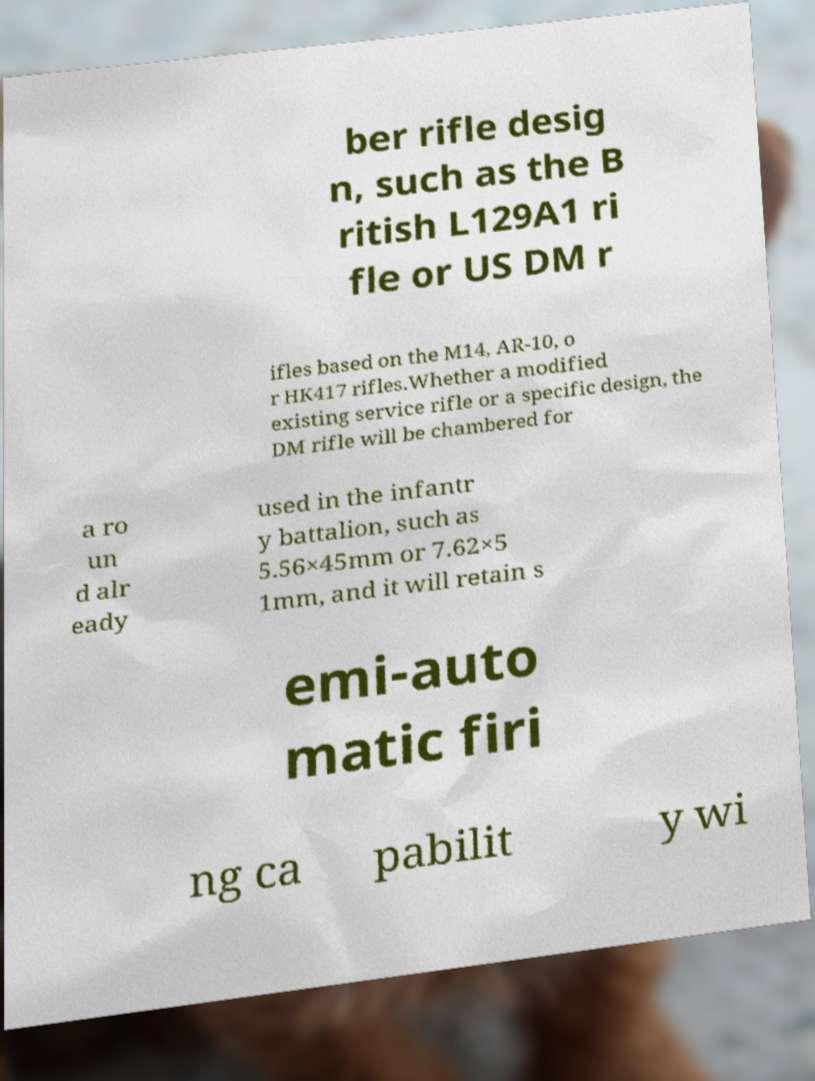What messages or text are displayed in this image? I need them in a readable, typed format. ber rifle desig n, such as the B ritish L129A1 ri fle or US DM r ifles based on the M14, AR-10, o r HK417 rifles.Whether a modified existing service rifle or a specific design, the DM rifle will be chambered for a ro un d alr eady used in the infantr y battalion, such as 5.56×45mm or 7.62×5 1mm, and it will retain s emi-auto matic firi ng ca pabilit y wi 